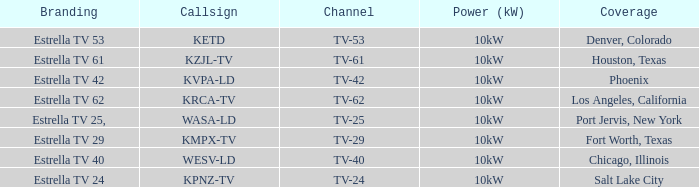Give me the full table as a dictionary. {'header': ['Branding', 'Callsign', 'Channel', 'Power (kW)', 'Coverage'], 'rows': [['Estrella TV 53', 'KETD', 'TV-53', '10kW', 'Denver, Colorado'], ['Estrella TV 61', 'KZJL-TV', 'TV-61', '10kW', 'Houston, Texas'], ['Estrella TV 42', 'KVPA-LD', 'TV-42', '10kW', 'Phoenix'], ['Estrella TV 62', 'KRCA-TV', 'TV-62', '10kW', 'Los Angeles, California'], ['Estrella TV 25,', 'WASA-LD', 'TV-25', '10kW', 'Port Jervis, New York'], ['Estrella TV 29', 'KMPX-TV', 'TV-29', '10kW', 'Fort Worth, Texas'], ['Estrella TV 40', 'WESV-LD', 'TV-40', '10kW', 'Chicago, Illinois'], ['Estrella TV 24', 'KPNZ-TV', 'TV-24', '10kW', 'Salt Lake City']]} List the branding name for channel tv-62. Estrella TV 62. 